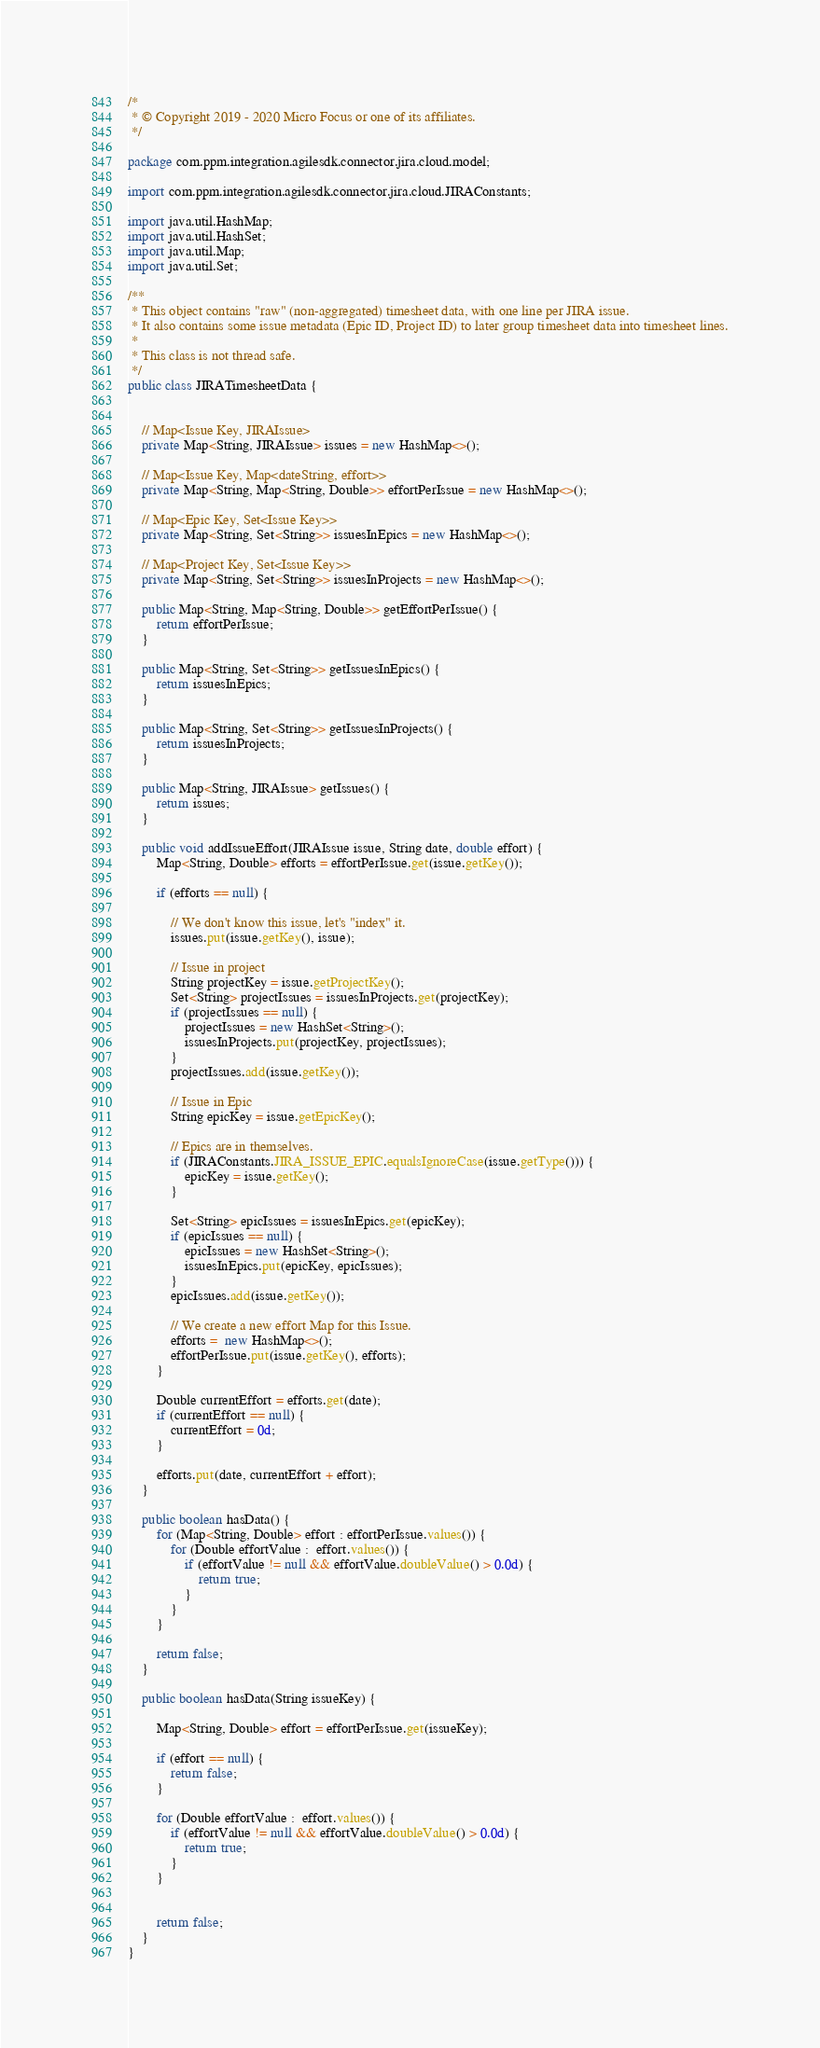<code> <loc_0><loc_0><loc_500><loc_500><_Java_>/*
 * © Copyright 2019 - 2020 Micro Focus or one of its affiliates.
 */

package com.ppm.integration.agilesdk.connector.jira.cloud.model;

import com.ppm.integration.agilesdk.connector.jira.cloud.JIRAConstants;

import java.util.HashMap;
import java.util.HashSet;
import java.util.Map;
import java.util.Set;

/**
 * This object contains "raw" (non-aggregated) timesheet data, with one line per JIRA issue.
 * It also contains some issue metadata (Epic ID, Project ID) to later group timesheet data into timesheet lines.
 *
 * This class is not thread safe.
 */
public class JIRATimesheetData {


    // Map<Issue Key, JIRAIssue>
    private Map<String, JIRAIssue> issues = new HashMap<>();

    // Map<Issue Key, Map<dateString, effort>>
    private Map<String, Map<String, Double>> effortPerIssue = new HashMap<>();

    // Map<Epic Key, Set<Issue Key>>
    private Map<String, Set<String>> issuesInEpics = new HashMap<>();

    // Map<Project Key, Set<Issue Key>>
    private Map<String, Set<String>> issuesInProjects = new HashMap<>();

    public Map<String, Map<String, Double>> getEffortPerIssue() {
        return effortPerIssue;
    }

    public Map<String, Set<String>> getIssuesInEpics() {
        return issuesInEpics;
    }

    public Map<String, Set<String>> getIssuesInProjects() {
        return issuesInProjects;
    }

    public Map<String, JIRAIssue> getIssues() {
        return issues;
    }

    public void addIssueEffort(JIRAIssue issue, String date, double effort) {
        Map<String, Double> efforts = effortPerIssue.get(issue.getKey());

        if (efforts == null) {

            // We don't know this issue, let's "index" it.
            issues.put(issue.getKey(), issue);

            // Issue in project
            String projectKey = issue.getProjectKey();
            Set<String> projectIssues = issuesInProjects.get(projectKey);
            if (projectIssues == null) {
                projectIssues = new HashSet<String>();
                issuesInProjects.put(projectKey, projectIssues);
            }
            projectIssues.add(issue.getKey());

            // Issue in Epic
            String epicKey = issue.getEpicKey();

            // Epics are in themselves.
            if (JIRAConstants.JIRA_ISSUE_EPIC.equalsIgnoreCase(issue.getType())) {
                epicKey = issue.getKey();
            }

            Set<String> epicIssues = issuesInEpics.get(epicKey);
            if (epicIssues == null) {
                epicIssues = new HashSet<String>();
                issuesInEpics.put(epicKey, epicIssues);
            }
            epicIssues.add(issue.getKey());

            // We create a new effort Map for this Issue.
            efforts =  new HashMap<>();
            effortPerIssue.put(issue.getKey(), efforts);
        }

        Double currentEffort = efforts.get(date);
        if (currentEffort == null) {
            currentEffort = 0d;
        }

        efforts.put(date, currentEffort + effort);
    }

    public boolean hasData() {
        for (Map<String, Double> effort : effortPerIssue.values()) {
            for (Double effortValue :  effort.values()) {
                if (effortValue != null && effortValue.doubleValue() > 0.0d) {
                    return true;
                }
            }
        }

        return false;
    }

    public boolean hasData(String issueKey) {

        Map<String, Double> effort = effortPerIssue.get(issueKey);

        if (effort == null) {
            return false;
        }

        for (Double effortValue :  effort.values()) {
            if (effortValue != null && effortValue.doubleValue() > 0.0d) {
                return true;
            }
        }


        return false;
    }
}
</code> 